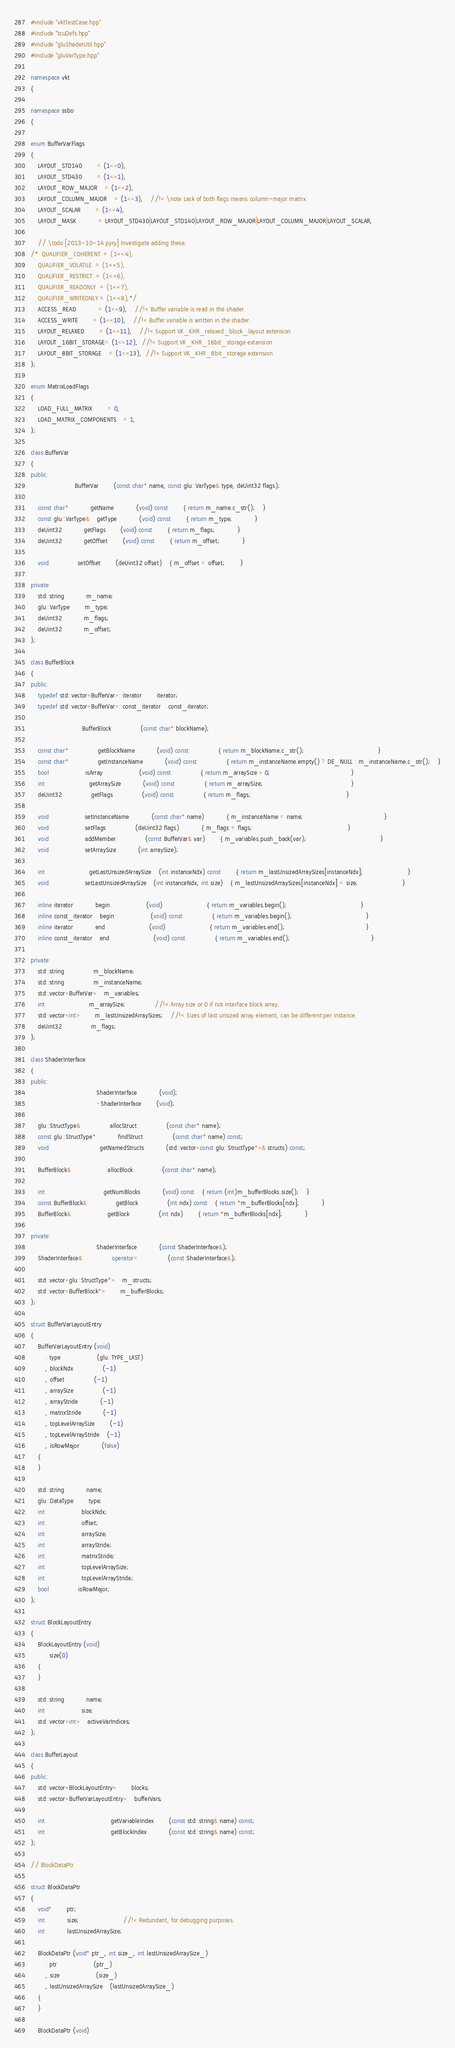<code> <loc_0><loc_0><loc_500><loc_500><_C++_>#include "vktTestCase.hpp"
#include "tcuDefs.hpp"
#include "gluShaderUtil.hpp"
#include "gluVarType.hpp"

namespace vkt
{

namespace ssbo
{

enum BufferVarFlags
{
	LAYOUT_STD140		= (1<<0),
	LAYOUT_STD430		= (1<<1),
	LAYOUT_ROW_MAJOR	= (1<<2),
	LAYOUT_COLUMN_MAJOR	= (1<<3),	//!< \note Lack of both flags means column-major matrix.
	LAYOUT_SCALAR		= (1<<4),
	LAYOUT_MASK			= LAYOUT_STD430|LAYOUT_STD140|LAYOUT_ROW_MAJOR|LAYOUT_COLUMN_MAJOR|LAYOUT_SCALAR,

	// \todo [2013-10-14 pyry] Investigate adding these.
/*	QUALIFIER_COHERENT	= (1<<4),
	QUALIFIER_VOLATILE	= (1<<5),
	QUALIFIER_RESTRICT	= (1<<6),
	QUALIFIER_READONLY	= (1<<7),
	QUALIFIER_WRITEONLY	= (1<<8),*/
	ACCESS_READ			= (1<<9),	//!< Buffer variable is read in the shader.
	ACCESS_WRITE		= (1<<10),	//!< Buffer variable is written in the shader.
	LAYOUT_RELAXED		= (1<<11),	//!< Support VK_KHR_relaxed_block_layout extension
	LAYOUT_16BIT_STORAGE= (1<<12),  //!< Support VK_KHR_16bit_storage extension
	LAYOUT_8BIT_STORAGE	= (1<<13),  //!< Support VK_KHR_8bit_storage extension
};

enum MatrixLoadFlags
{
	LOAD_FULL_MATRIX		= 0,
	LOAD_MATRIX_COMPONENTS	= 1,
};

class BufferVar
{
public:
						BufferVar		(const char* name, const glu::VarType& type, deUint32 flags);

	const char*			getName			(void) const		{ return m_name.c_str();	}
	const glu::VarType&	getType			(void) const		{ return m_type;			}
	deUint32			getFlags		(void) const		{ return m_flags;			}
	deUint32			getOffset		(void) const		{ return m_offset;			}

	void				setOffset		(deUint32 offset)	{ m_offset = offset;		}

private:
	std::string			m_name;
	glu::VarType		m_type;
	deUint32			m_flags;
	deUint32			m_offset;
};

class BufferBlock
{
public:
	typedef std::vector<BufferVar>::iterator		iterator;
	typedef std::vector<BufferVar>::const_iterator	const_iterator;

							BufferBlock				(const char* blockName);

	const char*				getBlockName			(void) const				{ return m_blockName.c_str();										}
	const char*				getInstanceName			(void) const				{ return m_instanceName.empty() ? DE_NULL : m_instanceName.c_str();	}
	bool					isArray					(void) const				{ return m_arraySize > 0;											}
	int						getArraySize			(void) const				{ return m_arraySize;												}
	deUint32				getFlags				(void) const				{ return m_flags;													}

	void					setInstanceName			(const char* name)			{ m_instanceName = name;											}
	void					setFlags				(deUint32 flags)			{ m_flags = flags;													}
	void					addMember				(const BufferVar& var)		{ m_variables.push_back(var);										}
	void					setArraySize			(int arraySize);

	int						getLastUnsizedArraySize	(int instanceNdx) const		{ return m_lastUnsizedArraySizes[instanceNdx];						}
	void					setLastUnsizedArraySize	(int instanceNdx, int size)	{ m_lastUnsizedArraySizes[instanceNdx] = size;						}

	inline iterator			begin					(void)						{ return m_variables.begin();										}
	inline const_iterator	begin					(void) const				{ return m_variables.begin();										}
	inline iterator			end						(void)						{ return m_variables.end();											}
	inline const_iterator	end						(void) const				{ return m_variables.end();											}

private:
	std::string				m_blockName;
	std::string				m_instanceName;
	std::vector<BufferVar>	m_variables;
	int						m_arraySize;				//!< Array size or 0 if not interface block array.
	std::vector<int>		m_lastUnsizedArraySizes;	//!< Sizes of last unsized array element, can be different per instance.
	deUint32				m_flags;
};

class ShaderInterface
{
public:
									ShaderInterface			(void);
									~ShaderInterface		(void);

	glu::StructType&				allocStruct				(const char* name);
	const glu::StructType*			findStruct				(const char* name) const;
	void							getNamedStructs			(std::vector<const glu::StructType*>& structs) const;

	BufferBlock&					allocBlock				(const char* name);

	int								getNumBlocks			(void) const	{ return (int)m_bufferBlocks.size();	}
	const BufferBlock&				getBlock				(int ndx) const	{ return *m_bufferBlocks[ndx];			}
	BufferBlock&					getBlock				(int ndx)		{ return *m_bufferBlocks[ndx];			}

private:
									ShaderInterface			(const ShaderInterface&);
	ShaderInterface&				operator=				(const ShaderInterface&);

	std::vector<glu::StructType*>	m_structs;
	std::vector<BufferBlock*>		m_bufferBlocks;
};

struct BufferVarLayoutEntry
{
	BufferVarLayoutEntry (void)
		: type					(glu::TYPE_LAST)
		, blockNdx				(-1)
		, offset				(-1)
		, arraySize				(-1)
		, arrayStride			(-1)
		, matrixStride			(-1)
		, topLevelArraySize		(-1)
		, topLevelArrayStride	(-1)
		, isRowMajor			(false)
	{
	}

	std::string			name;
	glu::DataType		type;
	int					blockNdx;
	int					offset;
	int					arraySize;
	int					arrayStride;
	int					matrixStride;
	int					topLevelArraySize;
	int					topLevelArrayStride;
	bool				isRowMajor;
};

struct BlockLayoutEntry
{
	BlockLayoutEntry (void)
		: size(0)
	{
	}

	std::string			name;
	int					size;
	std::vector<int>	activeVarIndices;
};

class BufferLayout
{
public:
	std::vector<BlockLayoutEntry>		blocks;
	std::vector<BufferVarLayoutEntry>	bufferVars;

	int									getVariableIndex		(const std::string& name) const;
	int									getBlockIndex			(const std::string& name) const;
};

// BlockDataPtr

struct BlockDataPtr
{
	void*		ptr;
	int			size;						//!< Redundant, for debugging purposes.
	int			lastUnsizedArraySize;

	BlockDataPtr (void* ptr_, int size_, int lastUnsizedArraySize_)
		: ptr					(ptr_)
		, size					(size_)
		, lastUnsizedArraySize	(lastUnsizedArraySize_)
	{
	}

	BlockDataPtr (void)</code> 